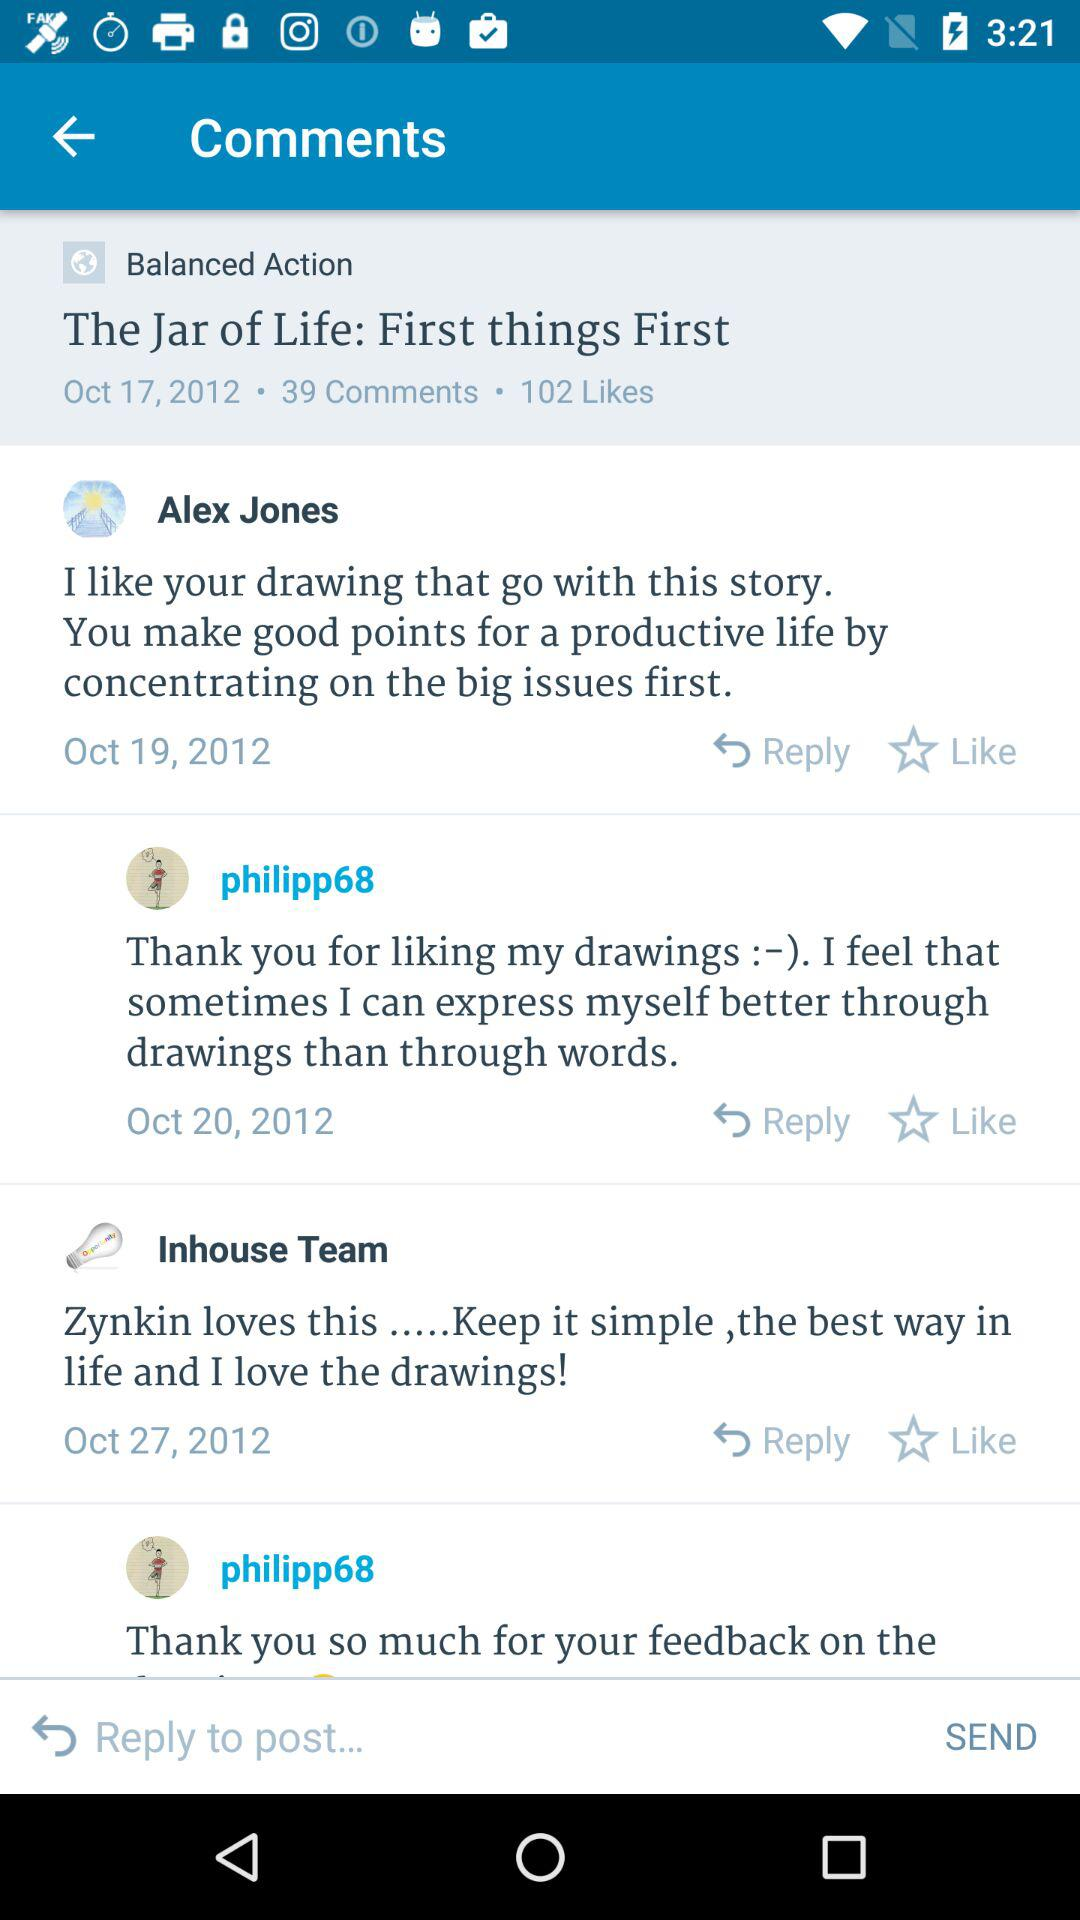On which date did the user Alex Jones comment? The user Alex Jones commented on October 19, 2012. 